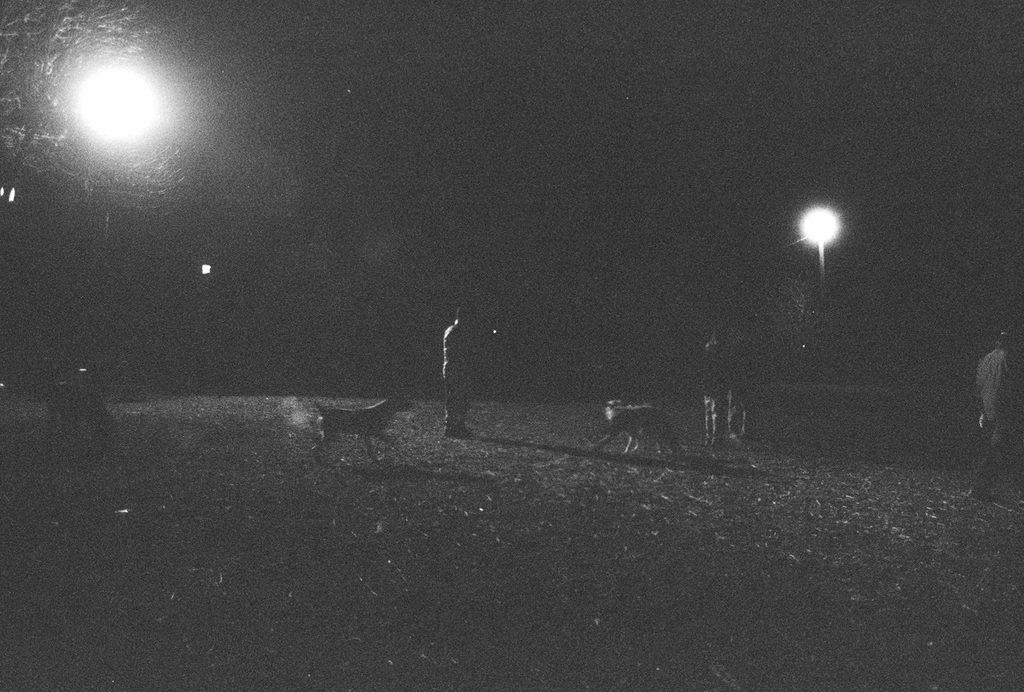What type of animals can be seen in the image? There are dogs in the image. What else is present in the image besides the dogs? There are people on the ground in the image. What can be seen illuminating the scene in the image? There are lights visible in the image. How would you describe the overall lighting in the image? The background of the image is dark. How many quince are being transported by the cars in the image? There are no cars or quince present in the image. 